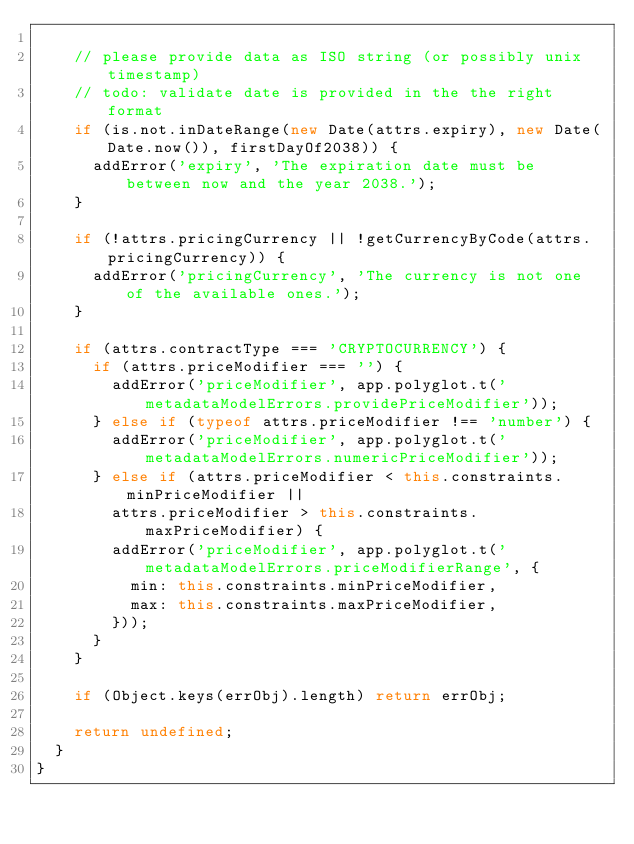<code> <loc_0><loc_0><loc_500><loc_500><_JavaScript_>
    // please provide data as ISO string (or possibly unix timestamp)
    // todo: validate date is provided in the the right format
    if (is.not.inDateRange(new Date(attrs.expiry), new Date(Date.now()), firstDayOf2038)) {
      addError('expiry', 'The expiration date must be between now and the year 2038.');
    }

    if (!attrs.pricingCurrency || !getCurrencyByCode(attrs.pricingCurrency)) {
      addError('pricingCurrency', 'The currency is not one of the available ones.');
    }

    if (attrs.contractType === 'CRYPTOCURRENCY') {
      if (attrs.priceModifier === '') {
        addError('priceModifier', app.polyglot.t('metadataModelErrors.providePriceModifier'));
      } else if (typeof attrs.priceModifier !== 'number') {
        addError('priceModifier', app.polyglot.t('metadataModelErrors.numericPriceModifier'));
      } else if (attrs.priceModifier < this.constraints.minPriceModifier ||
        attrs.priceModifier > this.constraints.maxPriceModifier) {
        addError('priceModifier', app.polyglot.t('metadataModelErrors.priceModifierRange', {
          min: this.constraints.minPriceModifier,
          max: this.constraints.maxPriceModifier,
        }));
      }
    }

    if (Object.keys(errObj).length) return errObj;

    return undefined;
  }
}
</code> 